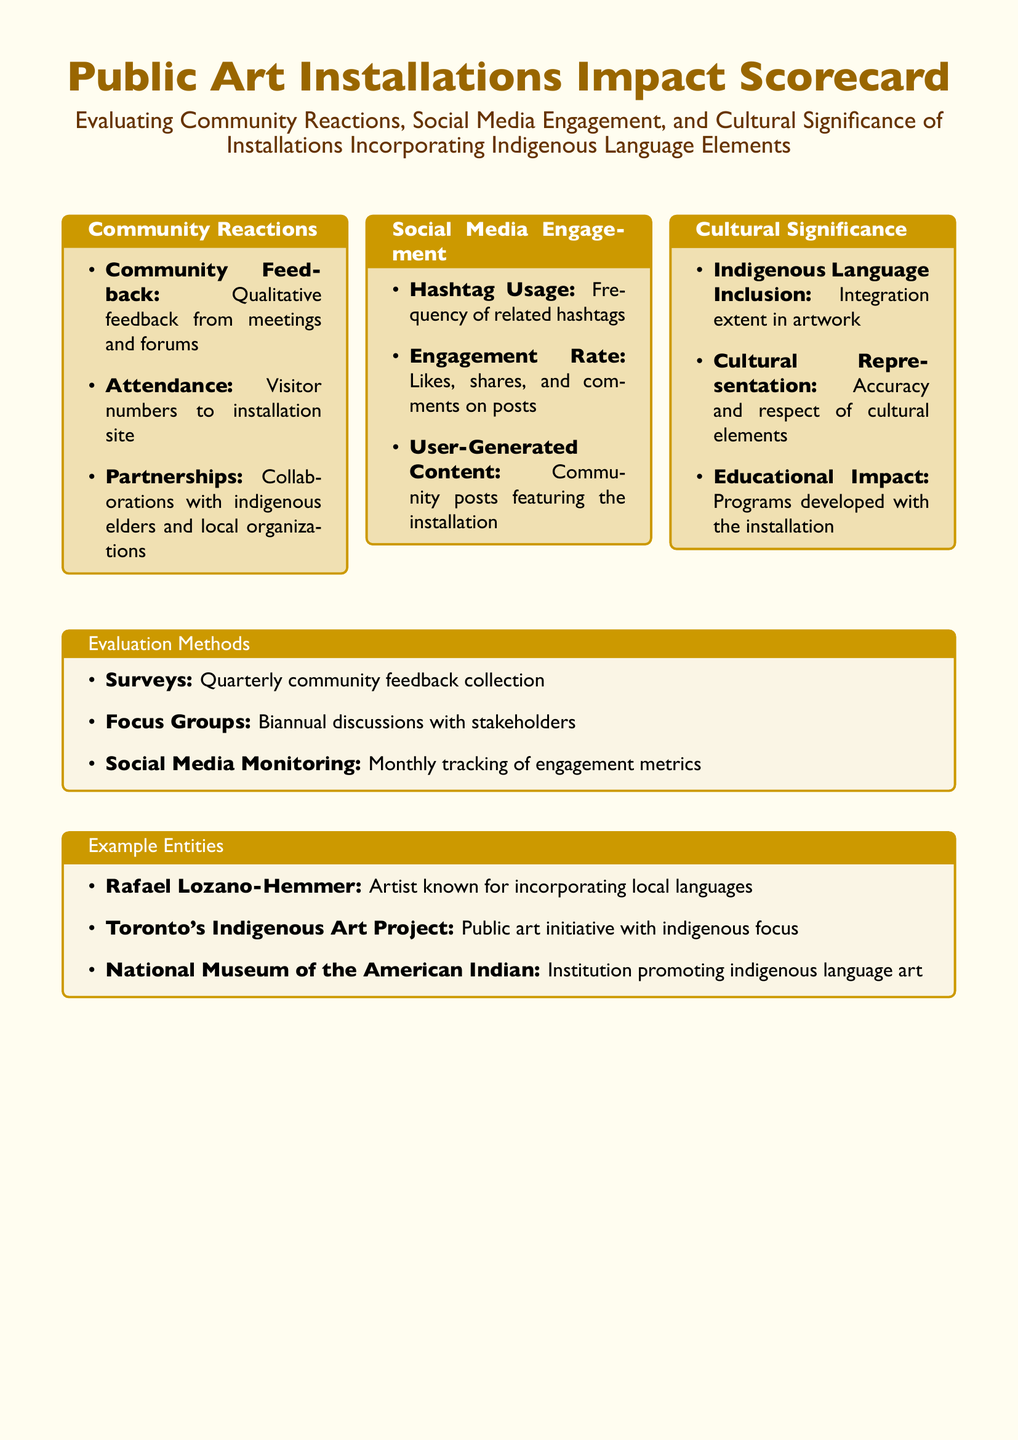What is the main title of the document? The main title provides an overview of the document's focus on public art installations and their impacts in the community.
Answer: Public Art Installations Impact Scorecard How many columns are used in the document layout? The document outlines content across three distinct categories, displayed in separate columns.
Answer: 3 What is the term used for qualitative feedback from community meetings? This term is specified under Community Reactions to signify direct opinions from the local community.
Answer: Community Feedback What type of monitoring is done monthly according to the evaluation methods? This monitoring pertains to the assessment of interactions on social media platforms related to the installations.
Answer: Social Media Monitoring What is one of the focuses of the "Cultural Significance" category? This focus highlights the incorporation of indigenous language and cultural elements within the installations.
Answer: Indigenous Language Inclusion What kind of discussions are held biannually as a method of evaluation? These discussions involve stakeholders and are aimed at gathering insights and opinions about the installations.
Answer: Focus Groups Which artist is mentioned as known for incorporating local languages in their work? This person's work is highlighted as an example of blending art with local linguistic elements.
Answer: Rafael Lozano-Hemmer What type of engagement metrics are tracked monthly? This refers to specific categories of interactions that measure the public's response to the artwork on social media.
Answer: Engagement Rate What programs are developed in connection with installations, as noted under cultural significance? These programs are created to educate the community and promote awareness of the artworks and their meanings.
Answer: Educational Impact 